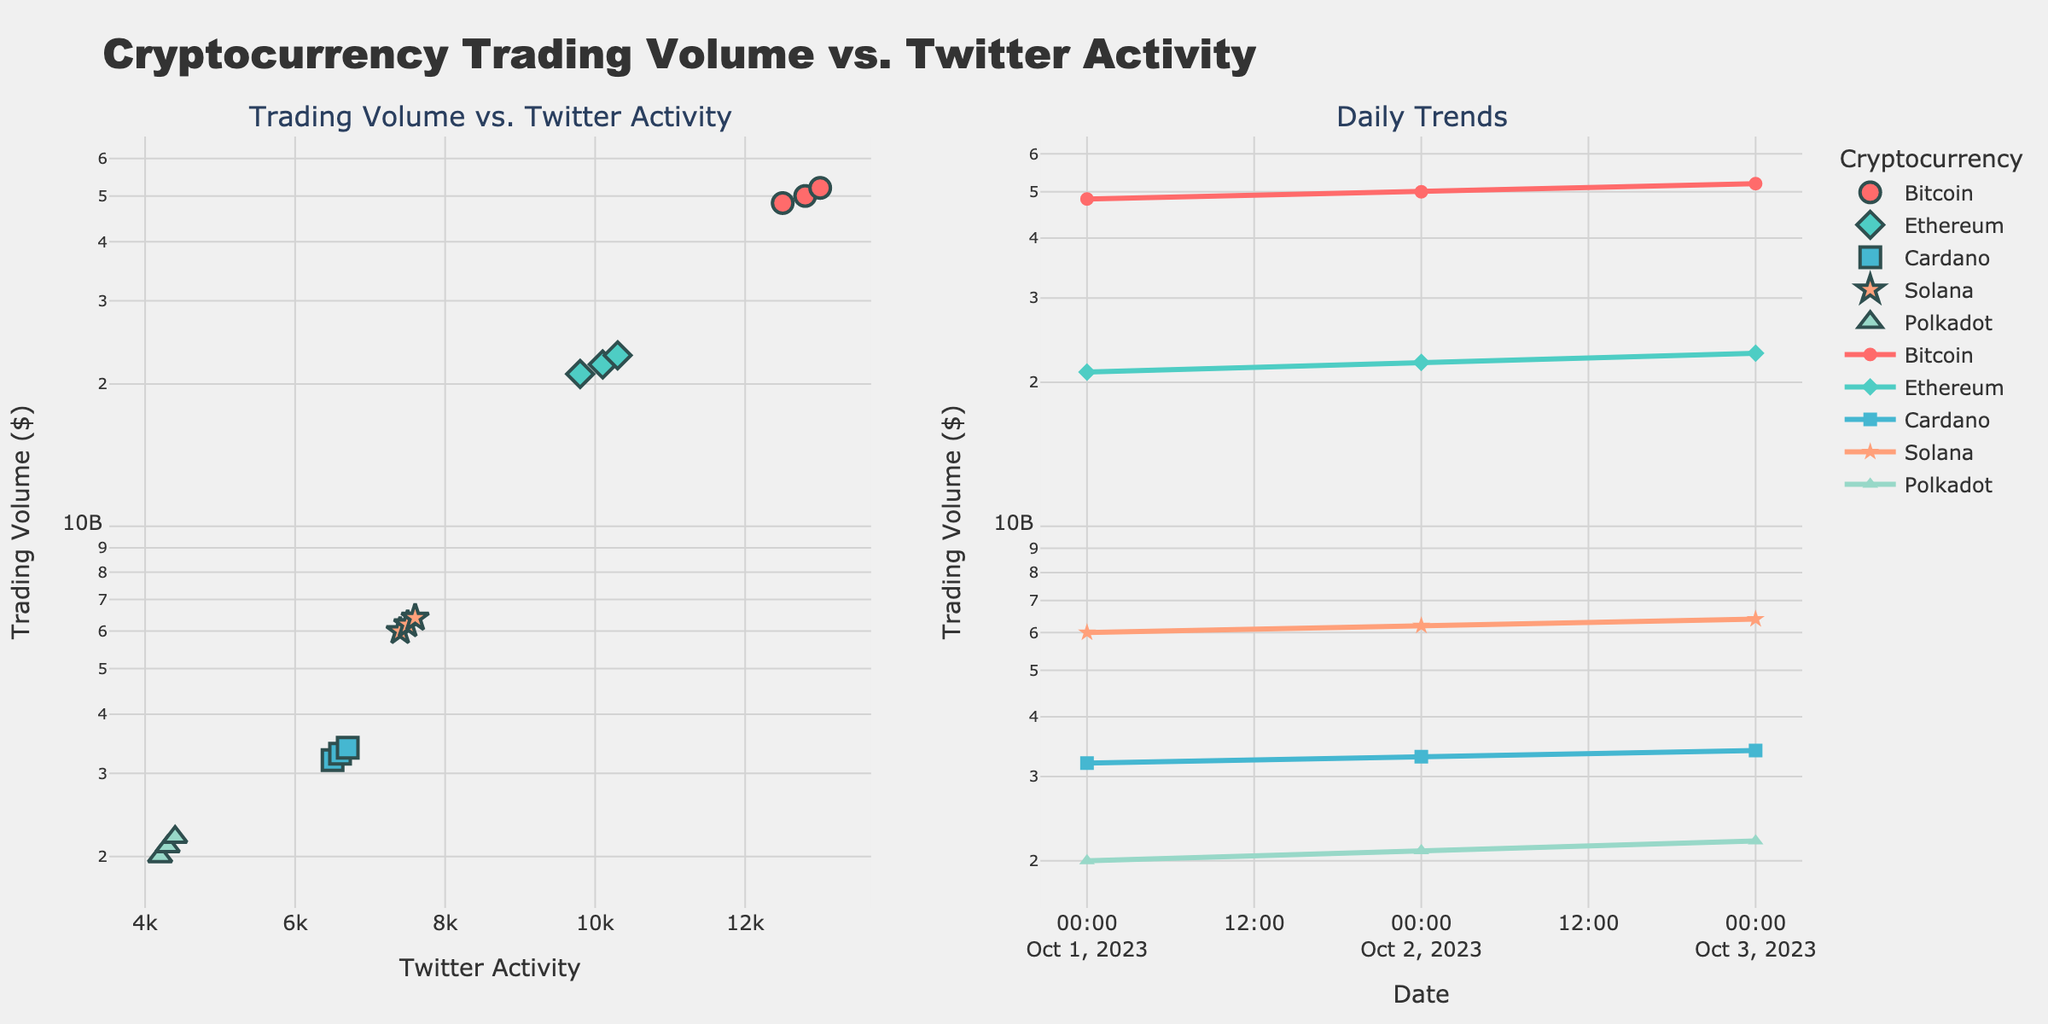What's the title of the overall figure? The title is located at the top of the figure. The figure's title is "Cryptocurrency Trading Volume vs. Twitter Activity".
Answer: Cryptocurrency Trading Volume vs. Twitter Activity What's the color used for Bitcoin data points in the scatter plot? Bitcoin uses the first color in the list, which is a bright red/pink shade. In this plot, Bitcoin data points are colored in this shade.
Answer: Bright red/pink Which cryptocurrency has the highest trading volume on October 3rd? To identify this, consider the line plot on the right and focus on the points for October 3rd. Bitcoin has the highest trading volume on this date.
Answer: Bitcoin What's the range of Twitter Activity values in the scatter plot? Look at the scatter plot's x-axis, which represents Twitter Activity. The values range from 4,200 to 13,000.
Answer: 4,200 to 13,000 Which cryptocurrency shows the most consistent trend between trading volume and Twitter activity in the scatter plot? Look for the scatter plot whose points form a more direct linear pattern. Bitcoin's points align more consistently, indicating a stronger correlation between trading volume and Twitter activity.
Answer: Bitcoin Compare the trading volumes of Ethereum and Cardano on October 2nd. Which one is higher, and by how much? By examining the line plot on the right side and focusing on October 2nd, Ethereum's trading volume is $22 billion, and Cardano's is $3.3 billion. The difference is $22 billion - $3.3 billion = $18.7 billion.
Answer: Ethereum by $18.7 billion What is the average trading volume of Solana across the three days? Solana's trading volumes are $6 billion, $6.2 billion, and $6.4 billion. Adding them together gives $18.6 billion, and dividing by 3, the average is $6.2 billion.
Answer: $6.2 billion Which day shows the highest overall Twitter activity for all cryptocurrencies combined? By summing the Twitter activity values for each day:
- October 1st: 12,500 (BTC) + 9,800 (ETH) + 6,500 (ADA) + 7,400 (SOL) + 4,200 (DOT) = 40,400
- October 2nd: 12,800 (BTC) + 10,100 (ETH) + 6,600 (ADA) + 7,500 (SOL) + 4,300 (DOT) = 41,300
- October 3rd: 13,000 (BTC) + 10,300 (ETH) + 6,700 (ADA) + 7,600 (SOL) + 4,400 (DOT) = 42,000
October 3rd has the highest total Twitter activity.
Answer: October 3rd Which cryptocurrency's trading volume shows the smallest change over the three days? By examining the line plot for each cryptocurrency:
- Bitcoin: 48.3B to 52B (3.7B change)
- Ethereum: 21B to 23B (2B change)
- Cardano: 3.2B to 3.4B (0.2B change)
- Solana: 6B to 6.4B (0.4B change)
- Polkadot: 2B to 2.2B (0.2B change)
Both Cardano and Polkadot have the smallest changes of 0.2B, but Polkadot changes by an even smaller proportion.
Answer: Polkadot 